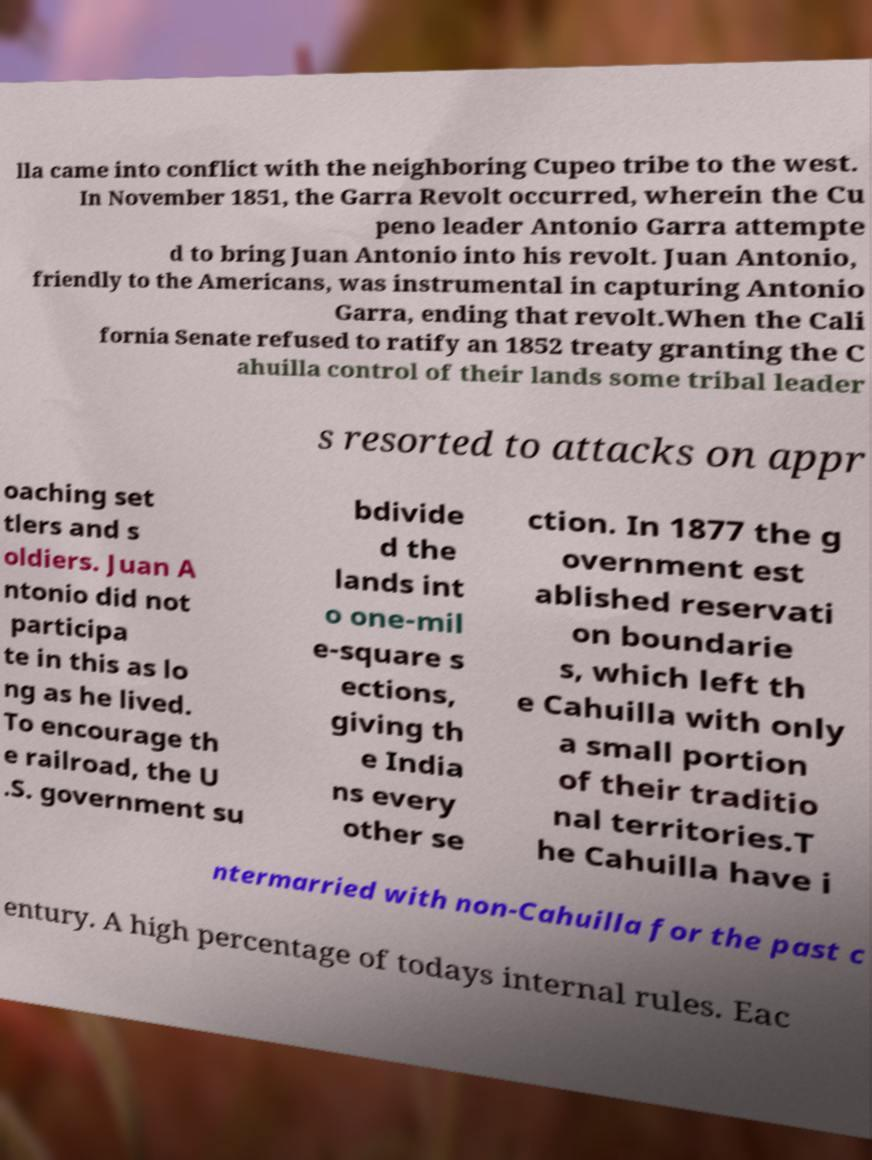Can you accurately transcribe the text from the provided image for me? lla came into conflict with the neighboring Cupeo tribe to the west. In November 1851, the Garra Revolt occurred, wherein the Cu peno leader Antonio Garra attempte d to bring Juan Antonio into his revolt. Juan Antonio, friendly to the Americans, was instrumental in capturing Antonio Garra, ending that revolt.When the Cali fornia Senate refused to ratify an 1852 treaty granting the C ahuilla control of their lands some tribal leader s resorted to attacks on appr oaching set tlers and s oldiers. Juan A ntonio did not participa te in this as lo ng as he lived. To encourage th e railroad, the U .S. government su bdivide d the lands int o one-mil e-square s ections, giving th e India ns every other se ction. In 1877 the g overnment est ablished reservati on boundarie s, which left th e Cahuilla with only a small portion of their traditio nal territories.T he Cahuilla have i ntermarried with non-Cahuilla for the past c entury. A high percentage of todays internal rules. Eac 